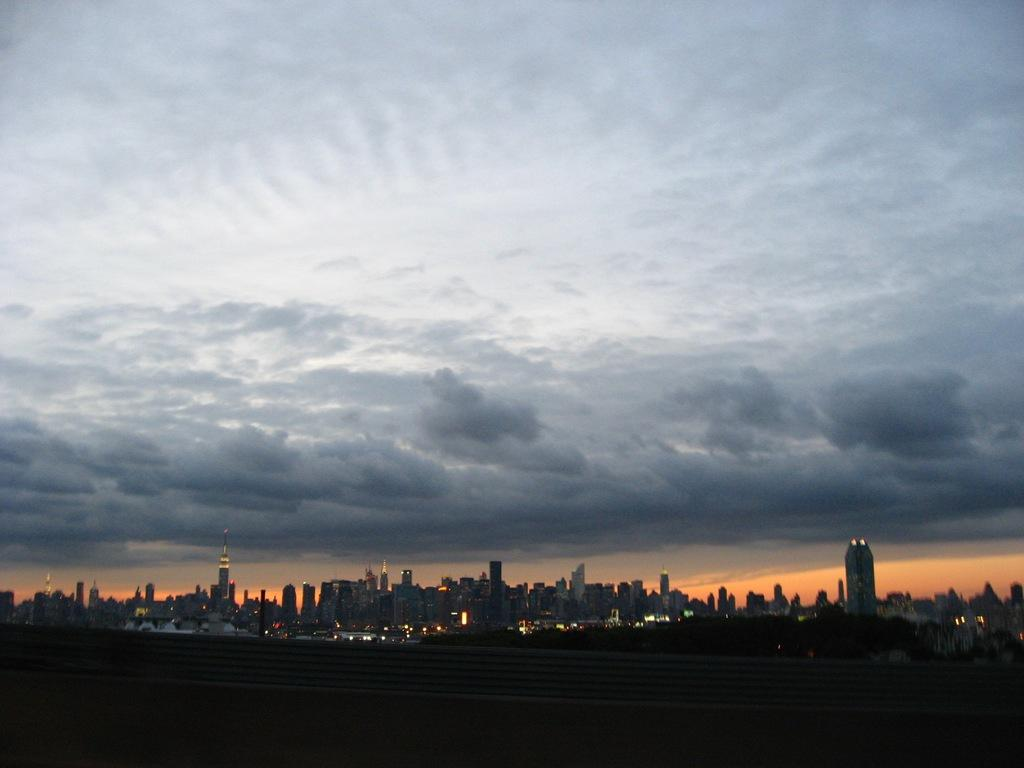What type of structures can be seen in the image? There are many buildings and skyscrapers in the image. What is visible in the sky in the image? There are clouds in the sky in the image. What is the lighting condition at the bottom of the image? There is darkness at the bottom of the image. What type of metal is used to make the hair visible in the image? There is no hair present in the image, and therefore no metal is used to make it visible. 